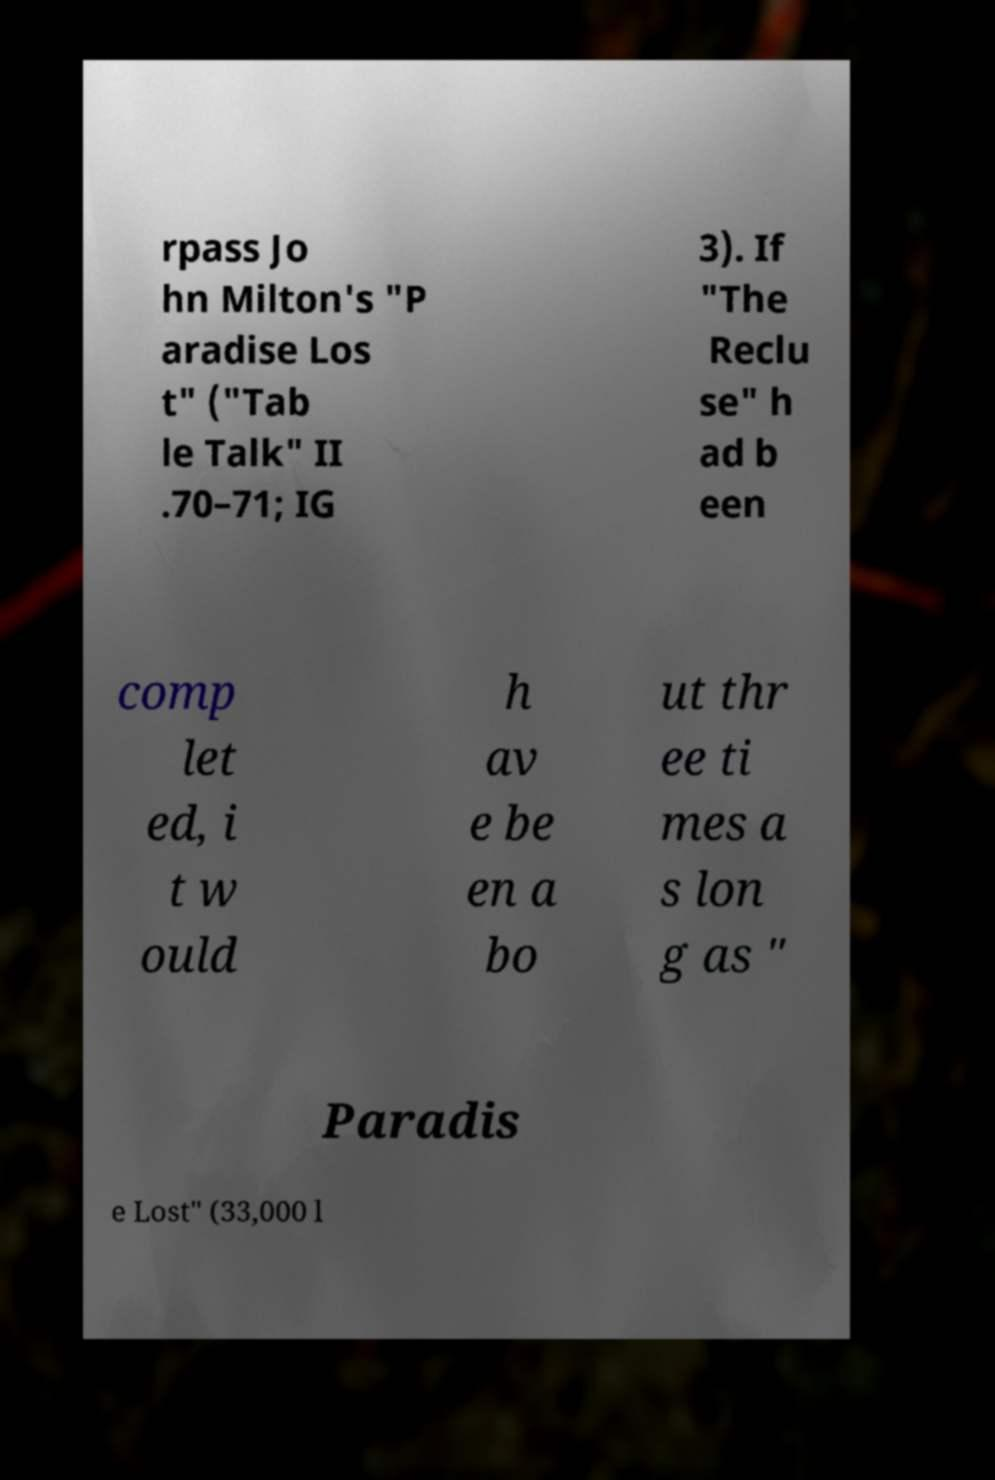Can you accurately transcribe the text from the provided image for me? rpass Jo hn Milton's "P aradise Los t" ("Tab le Talk" II .70–71; IG 3). If "The Reclu se" h ad b een comp let ed, i t w ould h av e be en a bo ut thr ee ti mes a s lon g as " Paradis e Lost" (33,000 l 